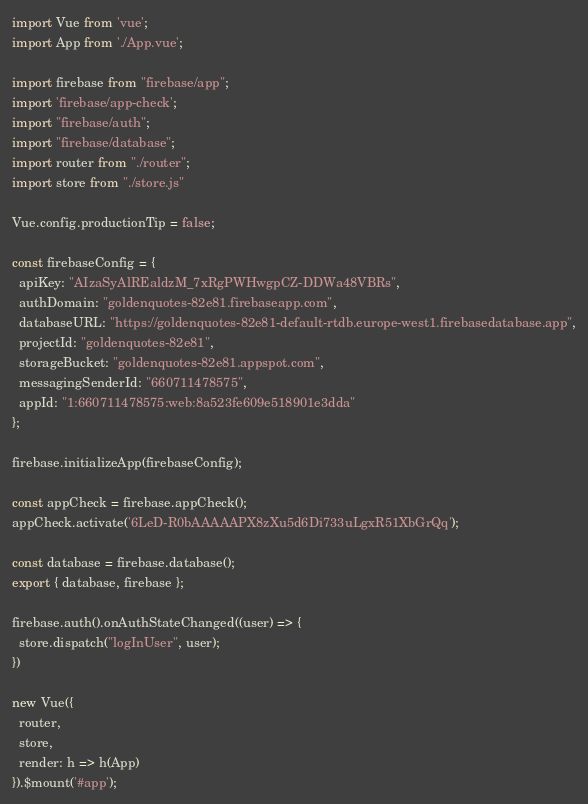<code> <loc_0><loc_0><loc_500><loc_500><_JavaScript_>import Vue from 'vue';
import App from './App.vue';

import firebase from "firebase/app";
import 'firebase/app-check';
import "firebase/auth";
import "firebase/database";
import router from "./router";
import store from "./store.js"

Vue.config.productionTip = false;

const firebaseConfig = {
  apiKey: "AIzaSyAlREaldzM_7xRgPWHwgpCZ-DDWa48VBRs",
  authDomain: "goldenquotes-82e81.firebaseapp.com",
  databaseURL: "https://goldenquotes-82e81-default-rtdb.europe-west1.firebasedatabase.app",
  projectId: "goldenquotes-82e81",
  storageBucket: "goldenquotes-82e81.appspot.com",
  messagingSenderId: "660711478575",
  appId: "1:660711478575:web:8a523fe609e518901e3dda"
};

firebase.initializeApp(firebaseConfig);

const appCheck = firebase.appCheck();
appCheck.activate('6LeD-R0bAAAAAPX8zXu5d6Di733uLgxR51XbGrQq');

const database = firebase.database();
export { database, firebase };

firebase.auth().onAuthStateChanged((user) => {
  store.dispatch("logInUser", user);
})

new Vue({
  router,
  store,
  render: h => h(App)
}).$mount('#app');
</code> 